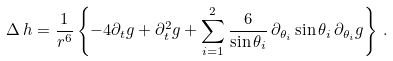<formula> <loc_0><loc_0><loc_500><loc_500>\Delta \, h = \frac { 1 } { r ^ { 6 } } \left \{ - 4 \partial _ { t } g + \partial _ { t } ^ { 2 } g + \sum _ { i = 1 } ^ { 2 } \frac { 6 } { \sin \theta _ { i } } \, \partial _ { \theta _ { i } } \sin \theta _ { i } \, \partial _ { \theta _ { i } } g \right \} \, .</formula> 